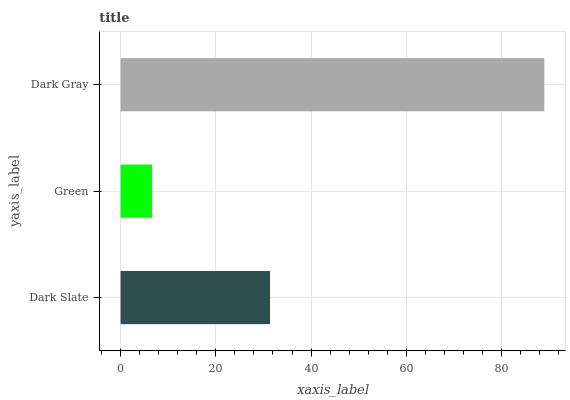Is Green the minimum?
Answer yes or no. Yes. Is Dark Gray the maximum?
Answer yes or no. Yes. Is Dark Gray the minimum?
Answer yes or no. No. Is Green the maximum?
Answer yes or no. No. Is Dark Gray greater than Green?
Answer yes or no. Yes. Is Green less than Dark Gray?
Answer yes or no. Yes. Is Green greater than Dark Gray?
Answer yes or no. No. Is Dark Gray less than Green?
Answer yes or no. No. Is Dark Slate the high median?
Answer yes or no. Yes. Is Dark Slate the low median?
Answer yes or no. Yes. Is Dark Gray the high median?
Answer yes or no. No. Is Green the low median?
Answer yes or no. No. 